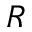<formula> <loc_0><loc_0><loc_500><loc_500>R</formula> 